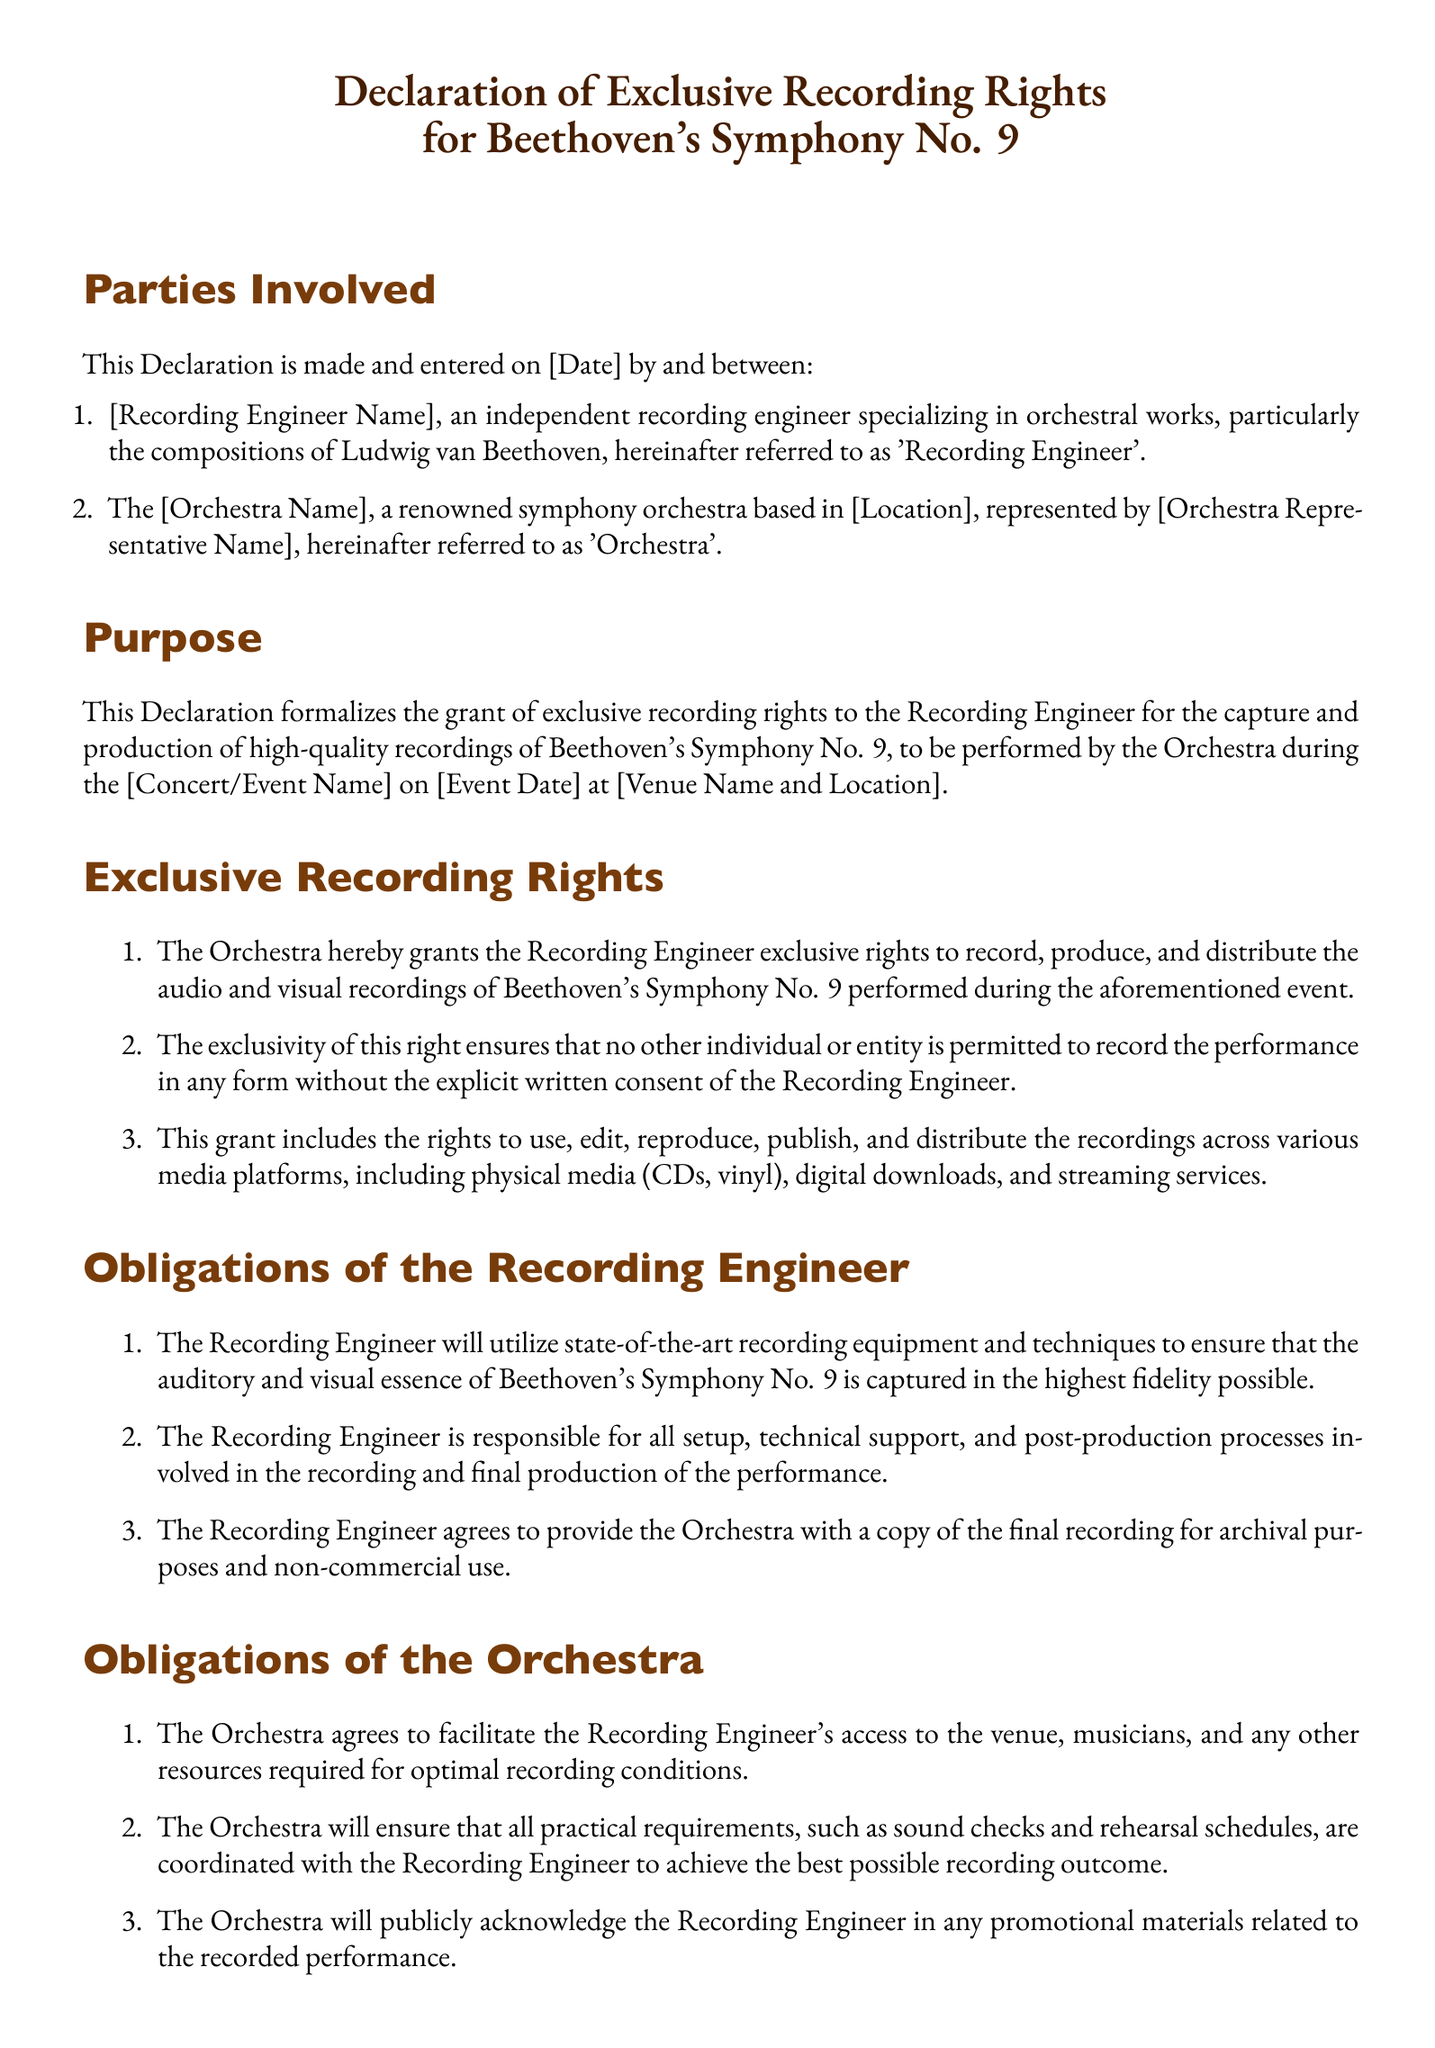What is the title of the document? The title is prominently displayed at the top of the document and describes the purpose of the Declaration.
Answer: Declaration of Exclusive Recording Rights for Beethoven's Symphony No. 9 Who is referred to as the 'Recording Engineer'? This refers to the individual named in the document who specializes in orchestral works, specifically Beethoven's compositions.
Answer: [Recording Engineer Name] What is the date of the event? The event date is mentioned in the purpose section of the Declaration where the performance will take place.
Answer: [Event Date] What symphony is covered by this Declaration? The Declaration specifies a particular symphony written by Ludwig van Beethoven.
Answer: Beethoven's Symphony No. 9 What must the Recording Engineer agree to provide to the Orchestra? This is stated in the obligations section regarding the recording provided for the Orchestra's use.
Answer: A copy of the final recording How long does the Declaration remain in effect? The duration of its effectiveness is outlined in the term and termination section of the document.
Answer: Until the completion of all obligations What is required for either party to terminate the Declaration? This is detailed in the termination section indicating the notice required for termination.
Answer: Written notice at least thirty (30) days in advance Who will publicly acknowledge the Recording Engineer? The obligations of the Orchestra specify this regarding promotional materials.
Answer: The Orchestra 